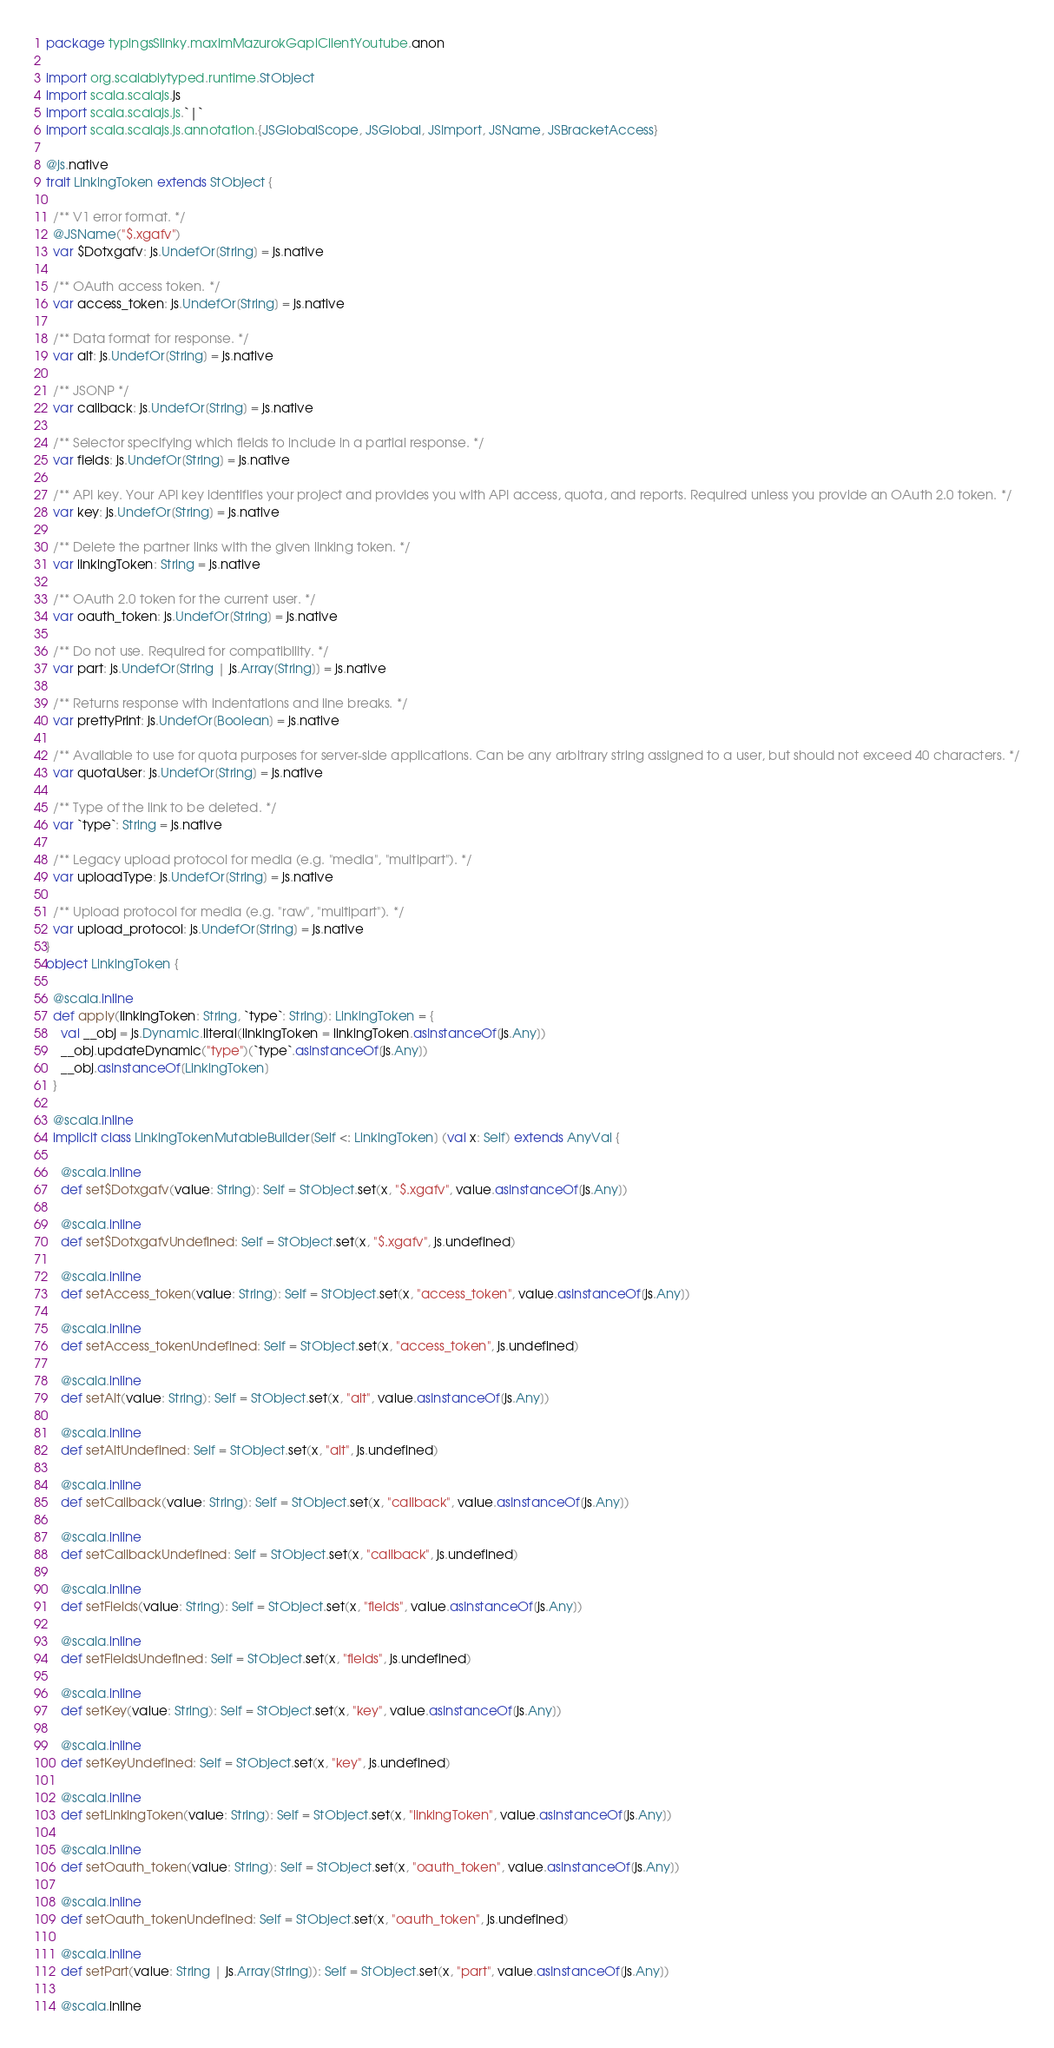<code> <loc_0><loc_0><loc_500><loc_500><_Scala_>package typingsSlinky.maximMazurokGapiClientYoutube.anon

import org.scalablytyped.runtime.StObject
import scala.scalajs.js
import scala.scalajs.js.`|`
import scala.scalajs.js.annotation.{JSGlobalScope, JSGlobal, JSImport, JSName, JSBracketAccess}

@js.native
trait LinkingToken extends StObject {
  
  /** V1 error format. */
  @JSName("$.xgafv")
  var $Dotxgafv: js.UndefOr[String] = js.native
  
  /** OAuth access token. */
  var access_token: js.UndefOr[String] = js.native
  
  /** Data format for response. */
  var alt: js.UndefOr[String] = js.native
  
  /** JSONP */
  var callback: js.UndefOr[String] = js.native
  
  /** Selector specifying which fields to include in a partial response. */
  var fields: js.UndefOr[String] = js.native
  
  /** API key. Your API key identifies your project and provides you with API access, quota, and reports. Required unless you provide an OAuth 2.0 token. */
  var key: js.UndefOr[String] = js.native
  
  /** Delete the partner links with the given linking token. */
  var linkingToken: String = js.native
  
  /** OAuth 2.0 token for the current user. */
  var oauth_token: js.UndefOr[String] = js.native
  
  /** Do not use. Required for compatibility. */
  var part: js.UndefOr[String | js.Array[String]] = js.native
  
  /** Returns response with indentations and line breaks. */
  var prettyPrint: js.UndefOr[Boolean] = js.native
  
  /** Available to use for quota purposes for server-side applications. Can be any arbitrary string assigned to a user, but should not exceed 40 characters. */
  var quotaUser: js.UndefOr[String] = js.native
  
  /** Type of the link to be deleted. */
  var `type`: String = js.native
  
  /** Legacy upload protocol for media (e.g. "media", "multipart"). */
  var uploadType: js.UndefOr[String] = js.native
  
  /** Upload protocol for media (e.g. "raw", "multipart"). */
  var upload_protocol: js.UndefOr[String] = js.native
}
object LinkingToken {
  
  @scala.inline
  def apply(linkingToken: String, `type`: String): LinkingToken = {
    val __obj = js.Dynamic.literal(linkingToken = linkingToken.asInstanceOf[js.Any])
    __obj.updateDynamic("type")(`type`.asInstanceOf[js.Any])
    __obj.asInstanceOf[LinkingToken]
  }
  
  @scala.inline
  implicit class LinkingTokenMutableBuilder[Self <: LinkingToken] (val x: Self) extends AnyVal {
    
    @scala.inline
    def set$Dotxgafv(value: String): Self = StObject.set(x, "$.xgafv", value.asInstanceOf[js.Any])
    
    @scala.inline
    def set$DotxgafvUndefined: Self = StObject.set(x, "$.xgafv", js.undefined)
    
    @scala.inline
    def setAccess_token(value: String): Self = StObject.set(x, "access_token", value.asInstanceOf[js.Any])
    
    @scala.inline
    def setAccess_tokenUndefined: Self = StObject.set(x, "access_token", js.undefined)
    
    @scala.inline
    def setAlt(value: String): Self = StObject.set(x, "alt", value.asInstanceOf[js.Any])
    
    @scala.inline
    def setAltUndefined: Self = StObject.set(x, "alt", js.undefined)
    
    @scala.inline
    def setCallback(value: String): Self = StObject.set(x, "callback", value.asInstanceOf[js.Any])
    
    @scala.inline
    def setCallbackUndefined: Self = StObject.set(x, "callback", js.undefined)
    
    @scala.inline
    def setFields(value: String): Self = StObject.set(x, "fields", value.asInstanceOf[js.Any])
    
    @scala.inline
    def setFieldsUndefined: Self = StObject.set(x, "fields", js.undefined)
    
    @scala.inline
    def setKey(value: String): Self = StObject.set(x, "key", value.asInstanceOf[js.Any])
    
    @scala.inline
    def setKeyUndefined: Self = StObject.set(x, "key", js.undefined)
    
    @scala.inline
    def setLinkingToken(value: String): Self = StObject.set(x, "linkingToken", value.asInstanceOf[js.Any])
    
    @scala.inline
    def setOauth_token(value: String): Self = StObject.set(x, "oauth_token", value.asInstanceOf[js.Any])
    
    @scala.inline
    def setOauth_tokenUndefined: Self = StObject.set(x, "oauth_token", js.undefined)
    
    @scala.inline
    def setPart(value: String | js.Array[String]): Self = StObject.set(x, "part", value.asInstanceOf[js.Any])
    
    @scala.inline</code> 